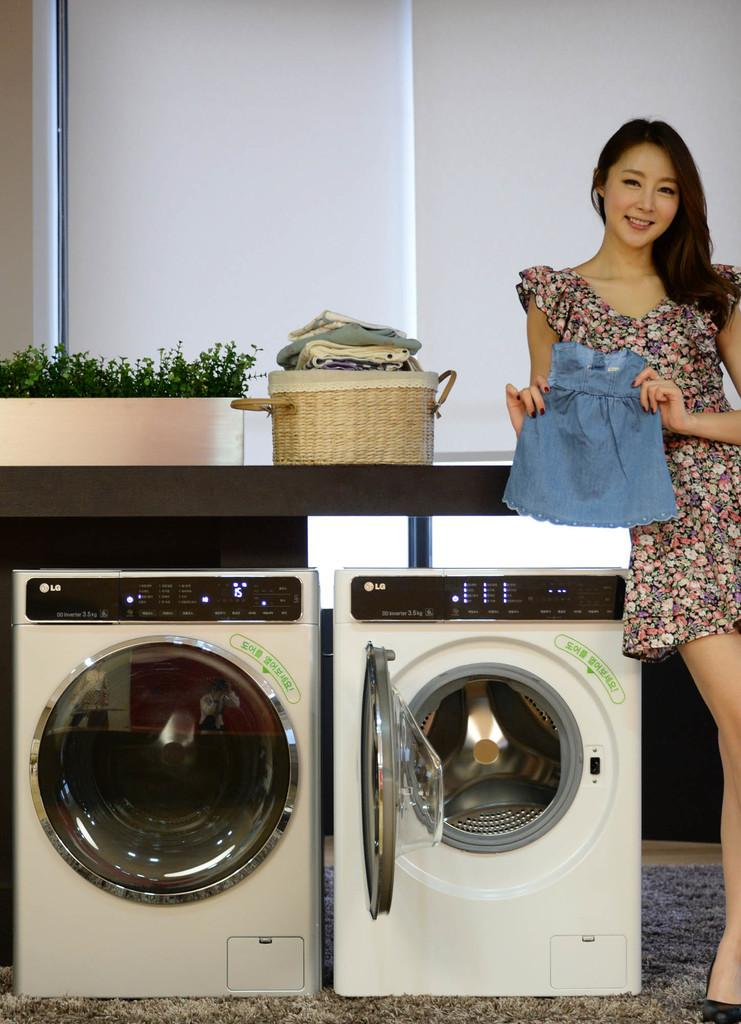<image>
Present a compact description of the photo's key features. A girl holding up a child's outfit in front of LG laundry machines. 